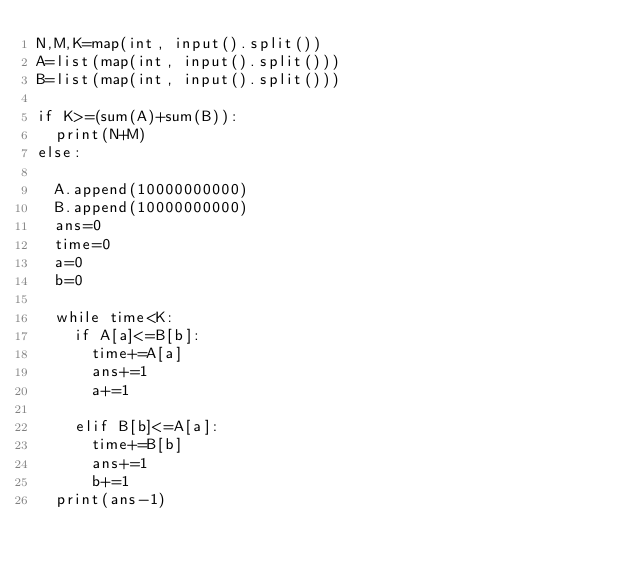<code> <loc_0><loc_0><loc_500><loc_500><_Python_>N,M,K=map(int, input().split())
A=list(map(int, input().split()))
B=list(map(int, input().split()))

if K>=(sum(A)+sum(B)):
  print(N+M)
else:

  A.append(10000000000)
  B.append(10000000000)
  ans=0
  time=0
  a=0
  b=0

  while time<K:
    if A[a]<=B[b]:
      time+=A[a]
      ans+=1
      a+=1

    elif B[b]<=A[a]:
      time+=B[b]
      ans+=1
      b+=1
  print(ans-1)
</code> 